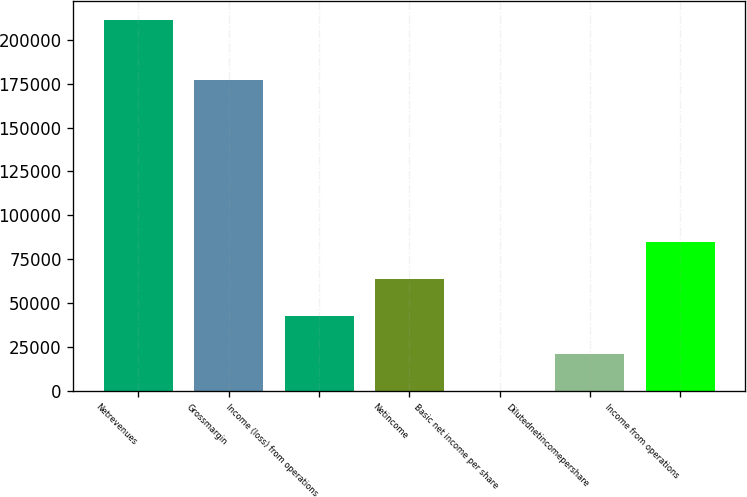<chart> <loc_0><loc_0><loc_500><loc_500><bar_chart><fcel>Netrevenues<fcel>Grossmargin<fcel>Income (loss) from operations<fcel>Netincome<fcel>Basic net income per share<fcel>Dilutednetincomepershare<fcel>Income from operations<nl><fcel>211401<fcel>177191<fcel>42280.3<fcel>63420.4<fcel>0.1<fcel>21140.2<fcel>84560.5<nl></chart> 